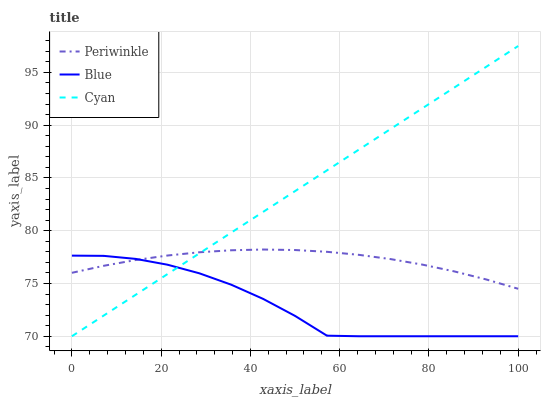Does Blue have the minimum area under the curve?
Answer yes or no. Yes. Does Cyan have the maximum area under the curve?
Answer yes or no. Yes. Does Periwinkle have the minimum area under the curve?
Answer yes or no. No. Does Periwinkle have the maximum area under the curve?
Answer yes or no. No. Is Cyan the smoothest?
Answer yes or no. Yes. Is Blue the roughest?
Answer yes or no. Yes. Is Periwinkle the smoothest?
Answer yes or no. No. Is Periwinkle the roughest?
Answer yes or no. No. Does Blue have the lowest value?
Answer yes or no. Yes. Does Periwinkle have the lowest value?
Answer yes or no. No. Does Cyan have the highest value?
Answer yes or no. Yes. Does Periwinkle have the highest value?
Answer yes or no. No. Does Blue intersect Periwinkle?
Answer yes or no. Yes. Is Blue less than Periwinkle?
Answer yes or no. No. Is Blue greater than Periwinkle?
Answer yes or no. No. 